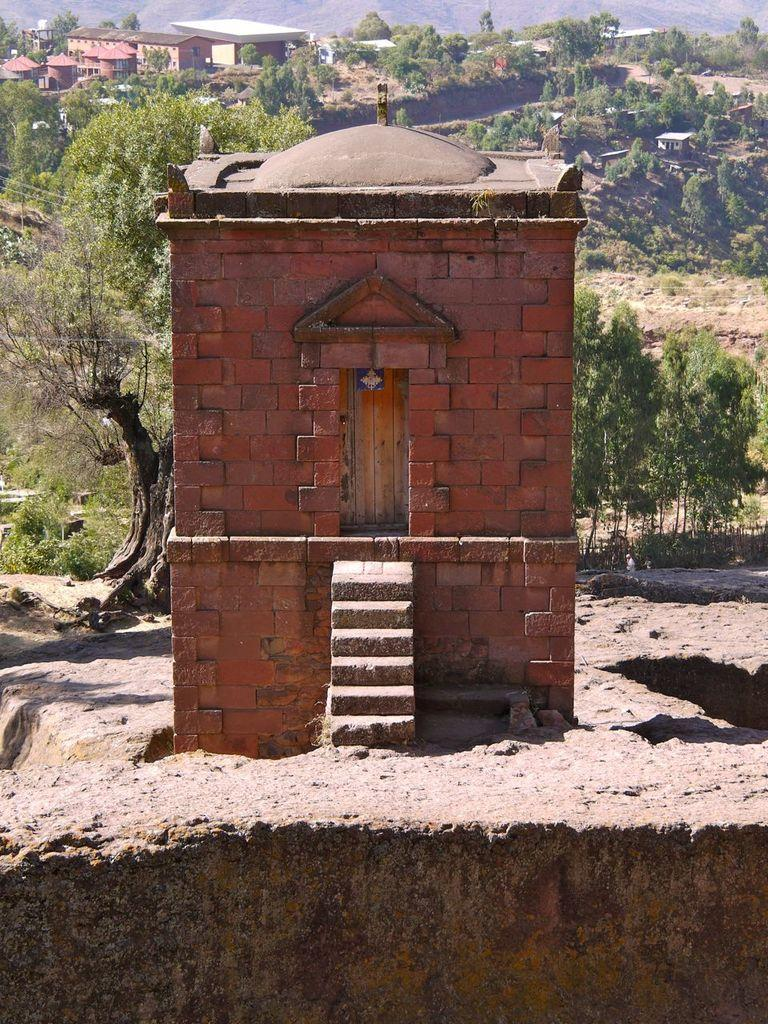What type of building is in the image? There is an old architecture building in the image. Where is the building situated? The building is located on a path. What can be seen behind the building? There are trees and houses behind the building. What type of prose can be heard being recited by the monkey in the image? There is no monkey present in the image, and therefore no prose can be heard being recited. 